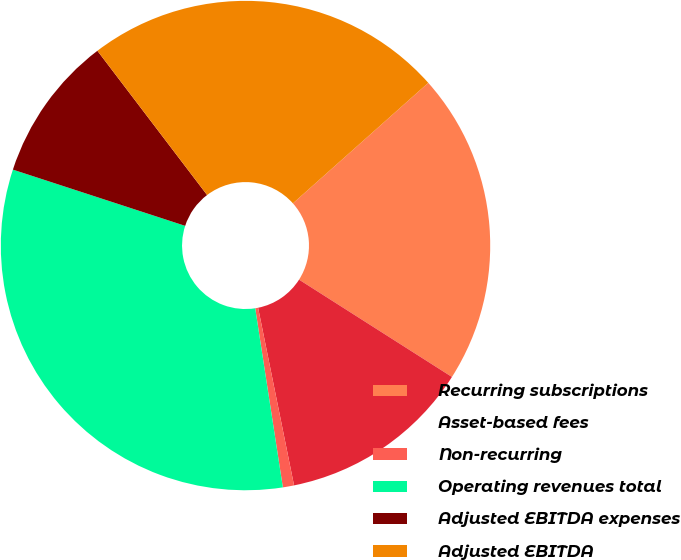Convert chart. <chart><loc_0><loc_0><loc_500><loc_500><pie_chart><fcel>Recurring subscriptions<fcel>Asset-based fees<fcel>Non-recurring<fcel>Operating revenues total<fcel>Adjusted EBITDA expenses<fcel>Adjusted EBITDA<nl><fcel>20.6%<fcel>12.8%<fcel>0.74%<fcel>32.46%<fcel>9.63%<fcel>23.77%<nl></chart> 